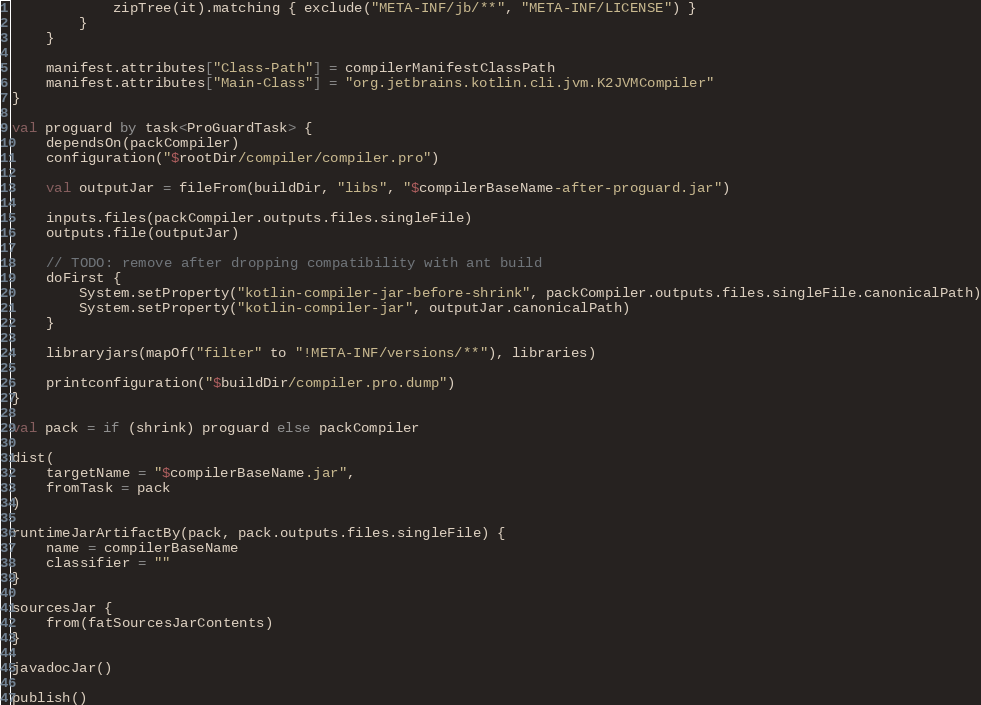<code> <loc_0><loc_0><loc_500><loc_500><_Kotlin_>            zipTree(it).matching { exclude("META-INF/jb/**", "META-INF/LICENSE") }
        }
    }

    manifest.attributes["Class-Path"] = compilerManifestClassPath
    manifest.attributes["Main-Class"] = "org.jetbrains.kotlin.cli.jvm.K2JVMCompiler"
}

val proguard by task<ProGuardTask> {
    dependsOn(packCompiler)
    configuration("$rootDir/compiler/compiler.pro")

    val outputJar = fileFrom(buildDir, "libs", "$compilerBaseName-after-proguard.jar")

    inputs.files(packCompiler.outputs.files.singleFile)
    outputs.file(outputJar)

    // TODO: remove after dropping compatibility with ant build
    doFirst {
        System.setProperty("kotlin-compiler-jar-before-shrink", packCompiler.outputs.files.singleFile.canonicalPath)
        System.setProperty("kotlin-compiler-jar", outputJar.canonicalPath)
    }

    libraryjars(mapOf("filter" to "!META-INF/versions/**"), libraries)

    printconfiguration("$buildDir/compiler.pro.dump")
}

val pack = if (shrink) proguard else packCompiler

dist(
    targetName = "$compilerBaseName.jar",
    fromTask = pack
)

runtimeJarArtifactBy(pack, pack.outputs.files.singleFile) {
    name = compilerBaseName
    classifier = ""
}

sourcesJar {
    from(fatSourcesJarContents)
}

javadocJar()

publish()
</code> 